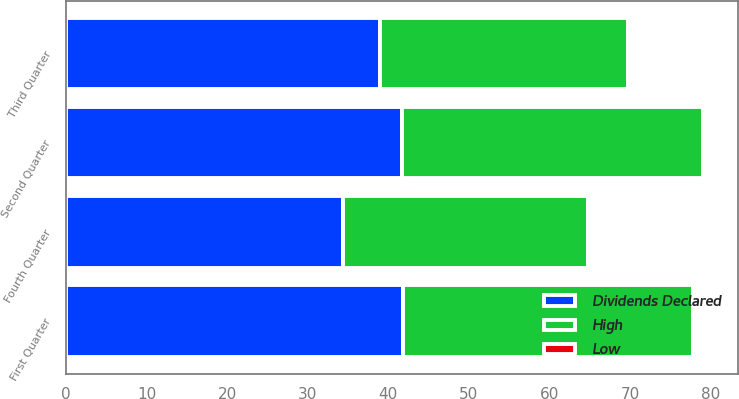<chart> <loc_0><loc_0><loc_500><loc_500><stacked_bar_chart><ecel><fcel>Fourth Quarter<fcel>Third Quarter<fcel>Second Quarter<fcel>First Quarter<nl><fcel>Dividends Declared<fcel>34.35<fcel>38.99<fcel>41.73<fcel>41.85<nl><fcel>High<fcel>30.39<fcel>30.82<fcel>37.4<fcel>35.93<nl><fcel>Low<fcel>0.27<fcel>0.27<fcel>0.27<fcel>0.25<nl></chart> 